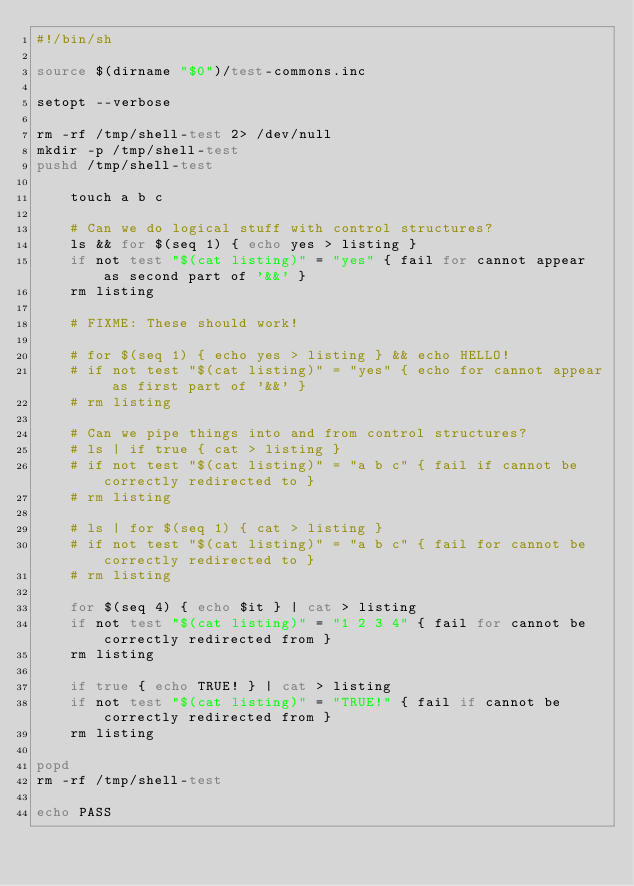<code> <loc_0><loc_0><loc_500><loc_500><_Bash_>#!/bin/sh

source $(dirname "$0")/test-commons.inc

setopt --verbose

rm -rf /tmp/shell-test 2> /dev/null
mkdir -p /tmp/shell-test
pushd /tmp/shell-test

    touch a b c

    # Can we do logical stuff with control structures?
    ls && for $(seq 1) { echo yes > listing }
    if not test "$(cat listing)" = "yes" { fail for cannot appear as second part of '&&' }
    rm listing

    # FIXME: These should work!

    # for $(seq 1) { echo yes > listing } && echo HELLO!
    # if not test "$(cat listing)" = "yes" { echo for cannot appear as first part of '&&' }
    # rm listing

    # Can we pipe things into and from control structures?
    # ls | if true { cat > listing }
    # if not test "$(cat listing)" = "a b c" { fail if cannot be correctly redirected to }
    # rm listing

    # ls | for $(seq 1) { cat > listing }
    # if not test "$(cat listing)" = "a b c" { fail for cannot be correctly redirected to }
    # rm listing

    for $(seq 4) { echo $it } | cat > listing
    if not test "$(cat listing)" = "1 2 3 4" { fail for cannot be correctly redirected from }
    rm listing

    if true { echo TRUE! } | cat > listing
    if not test "$(cat listing)" = "TRUE!" { fail if cannot be correctly redirected from }
    rm listing

popd
rm -rf /tmp/shell-test

echo PASS
</code> 